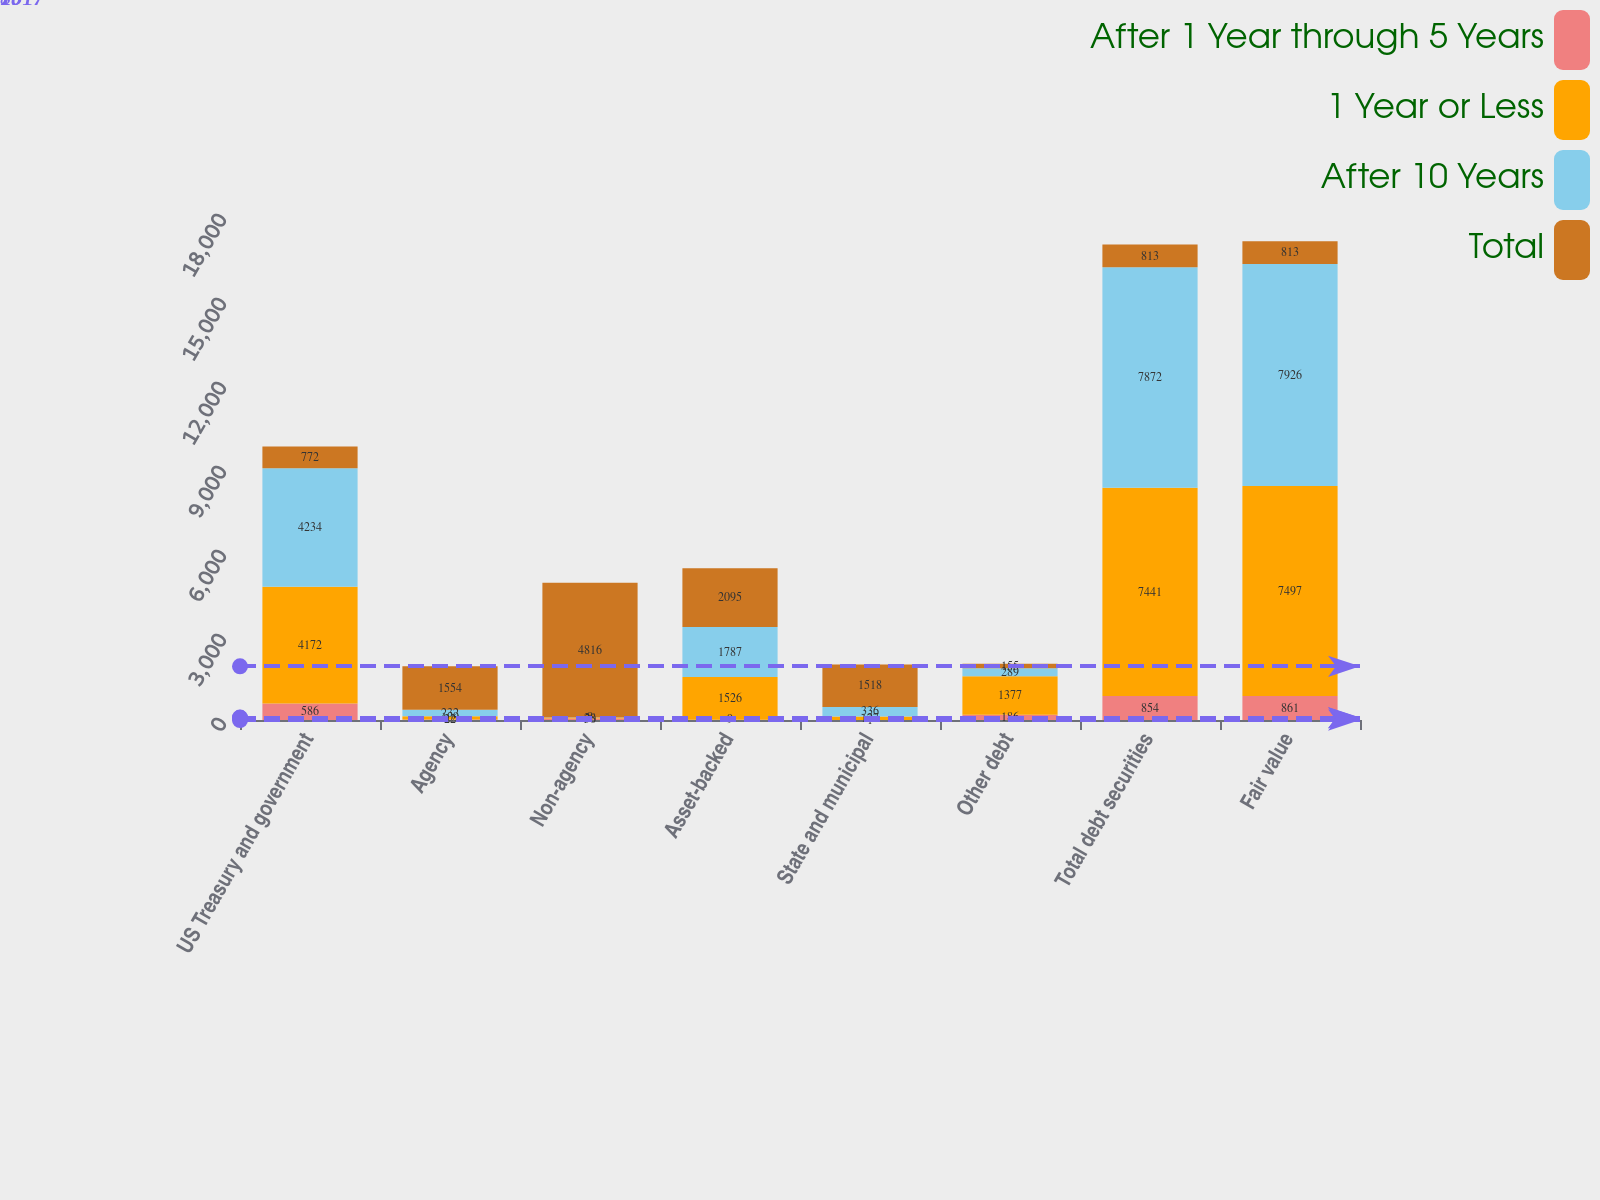<chart> <loc_0><loc_0><loc_500><loc_500><stacked_bar_chart><ecel><fcel>US Treasury and government<fcel>Agency<fcel>Non-agency<fcel>Asset-backed<fcel>State and municipal<fcel>Other debt<fcel>Total debt securities<fcel>Fair value<nl><fcel>After 1 Year through 5 Years<fcel>586<fcel>22<fcel>50<fcel>9<fcel>1<fcel>186<fcel>854<fcel>861<nl><fcel>1 Year or Less<fcel>4172<fcel>109<fcel>28<fcel>1526<fcel>127<fcel>1377<fcel>7441<fcel>7497<nl><fcel>After 10 Years<fcel>4234<fcel>232<fcel>8<fcel>1787<fcel>336<fcel>289<fcel>7872<fcel>7926<nl><fcel>Total<fcel>772<fcel>1554<fcel>4816<fcel>2095<fcel>1518<fcel>155<fcel>813<fcel>813<nl></chart> 